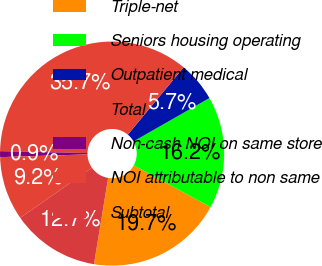Convert chart to OTSL. <chart><loc_0><loc_0><loc_500><loc_500><pie_chart><fcel>Triple-net<fcel>Seniors housing operating<fcel>Outpatient medical<fcel>Total<fcel>Non-cash NOI on same store<fcel>NOI attributable to non same<fcel>Subtotal<nl><fcel>19.66%<fcel>16.18%<fcel>5.73%<fcel>35.67%<fcel>0.85%<fcel>9.21%<fcel>12.7%<nl></chart> 